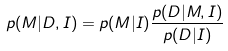Convert formula to latex. <formula><loc_0><loc_0><loc_500><loc_500>p ( M | D , I ) = p ( M | I ) \frac { p ( D | M , I ) } { p ( D | I ) }</formula> 